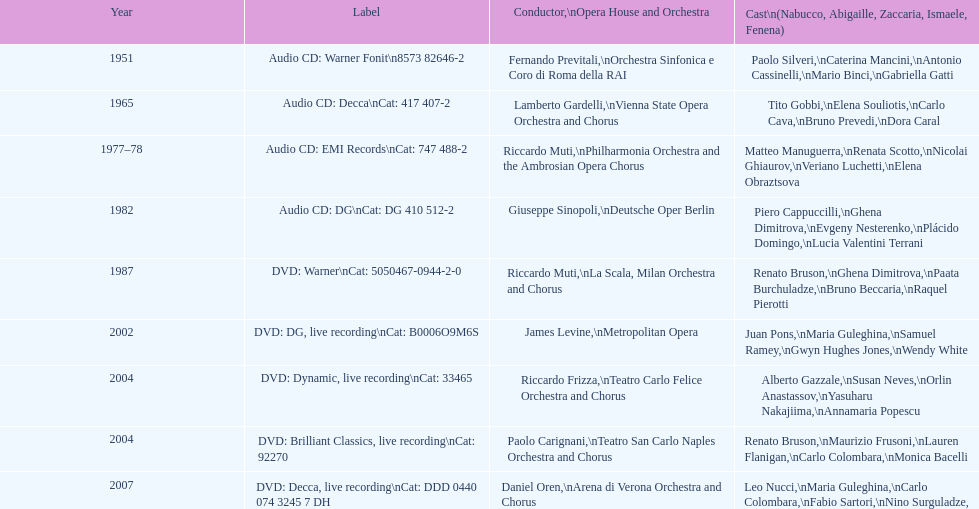How many recordings of nabucco have been made? 9. 